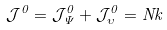Convert formula to latex. <formula><loc_0><loc_0><loc_500><loc_500>\mathcal { J } ^ { 0 } = \mathcal { J } _ { \Psi } ^ { 0 } + \mathcal { J } _ { \upsilon } ^ { 0 } = N k</formula> 